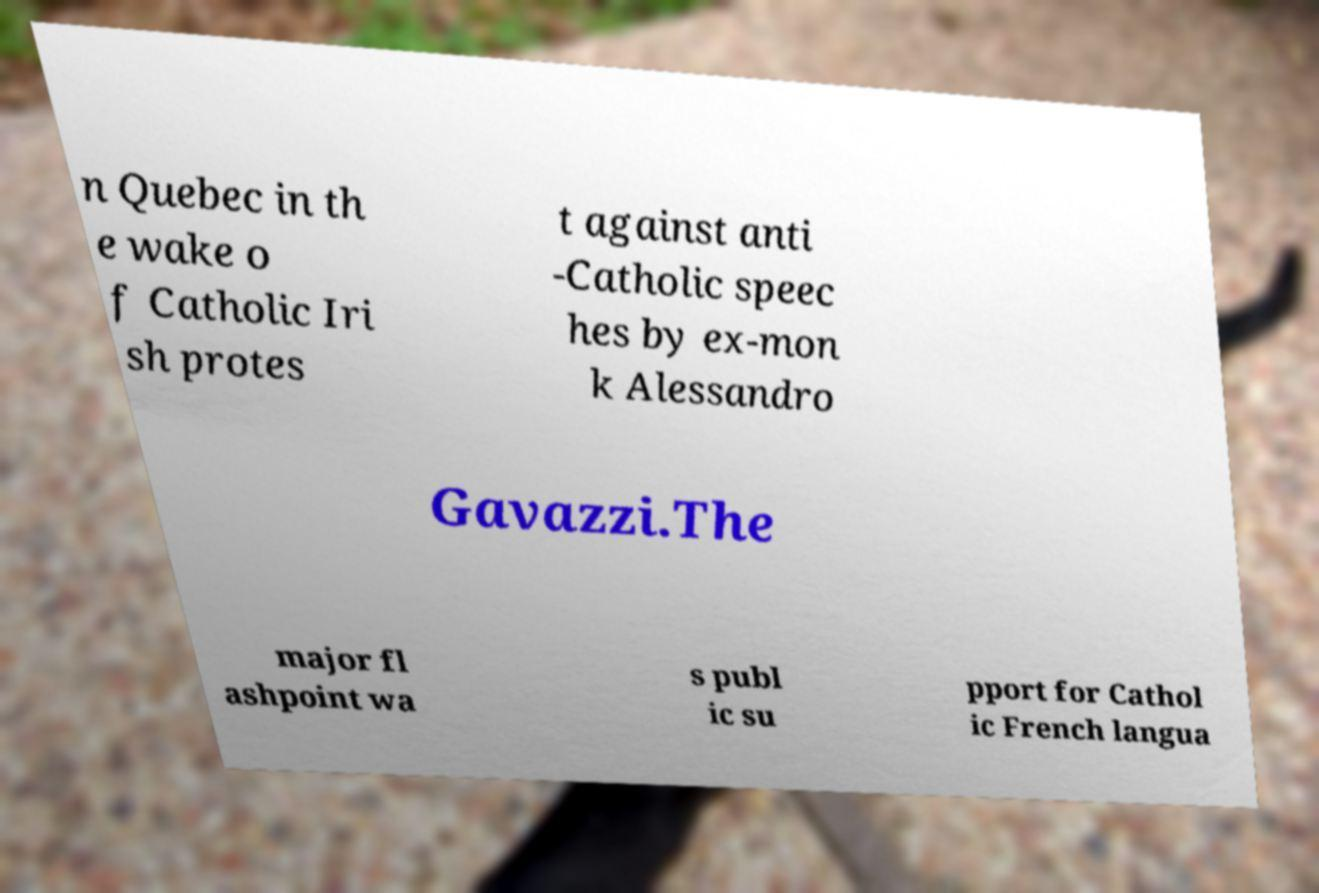Please read and relay the text visible in this image. What does it say? n Quebec in th e wake o f Catholic Iri sh protes t against anti -Catholic speec hes by ex-mon k Alessandro Gavazzi.The major fl ashpoint wa s publ ic su pport for Cathol ic French langua 